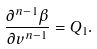<formula> <loc_0><loc_0><loc_500><loc_500>\frac { \partial ^ { n - 1 } \beta } { \partial v ^ { n - 1 } } = Q _ { 1 } .</formula> 